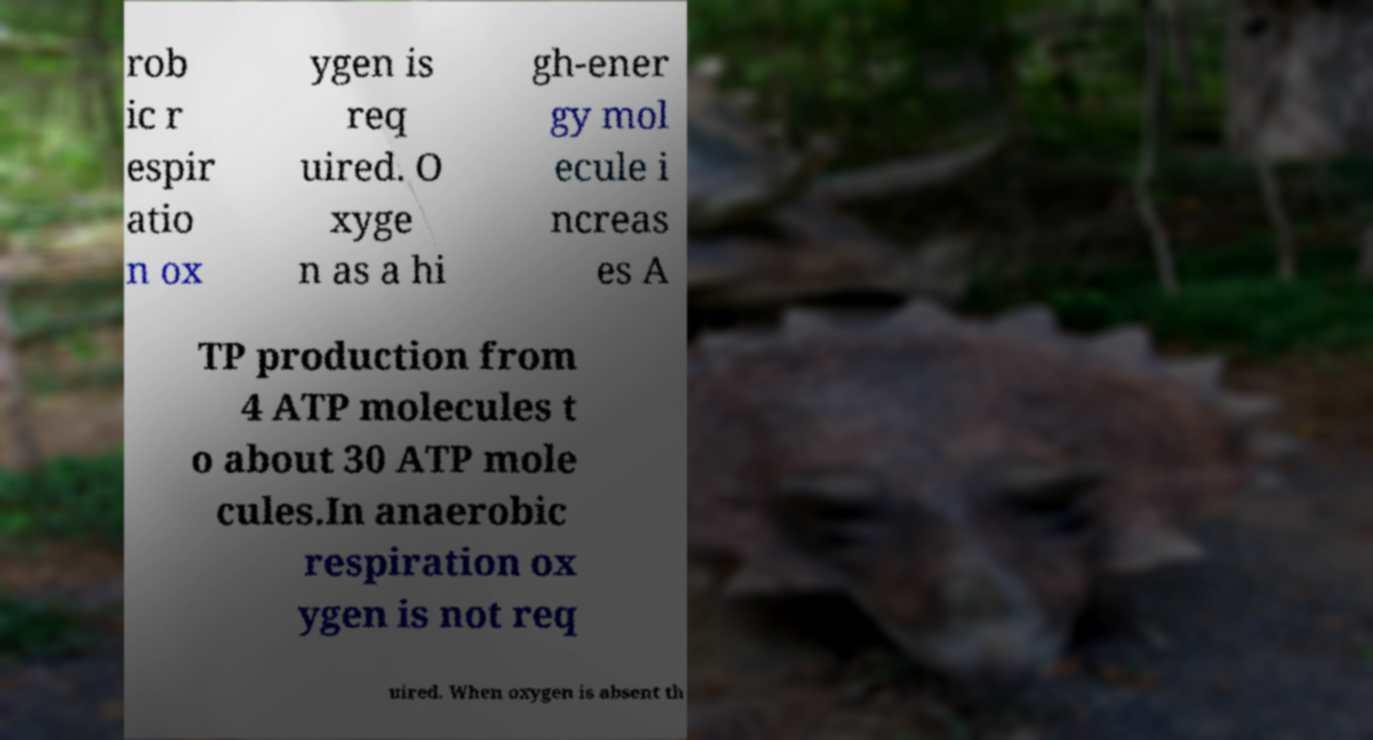Can you read and provide the text displayed in the image?This photo seems to have some interesting text. Can you extract and type it out for me? rob ic r espir atio n ox ygen is req uired. O xyge n as a hi gh-ener gy mol ecule i ncreas es A TP production from 4 ATP molecules t o about 30 ATP mole cules.In anaerobic respiration ox ygen is not req uired. When oxygen is absent th 